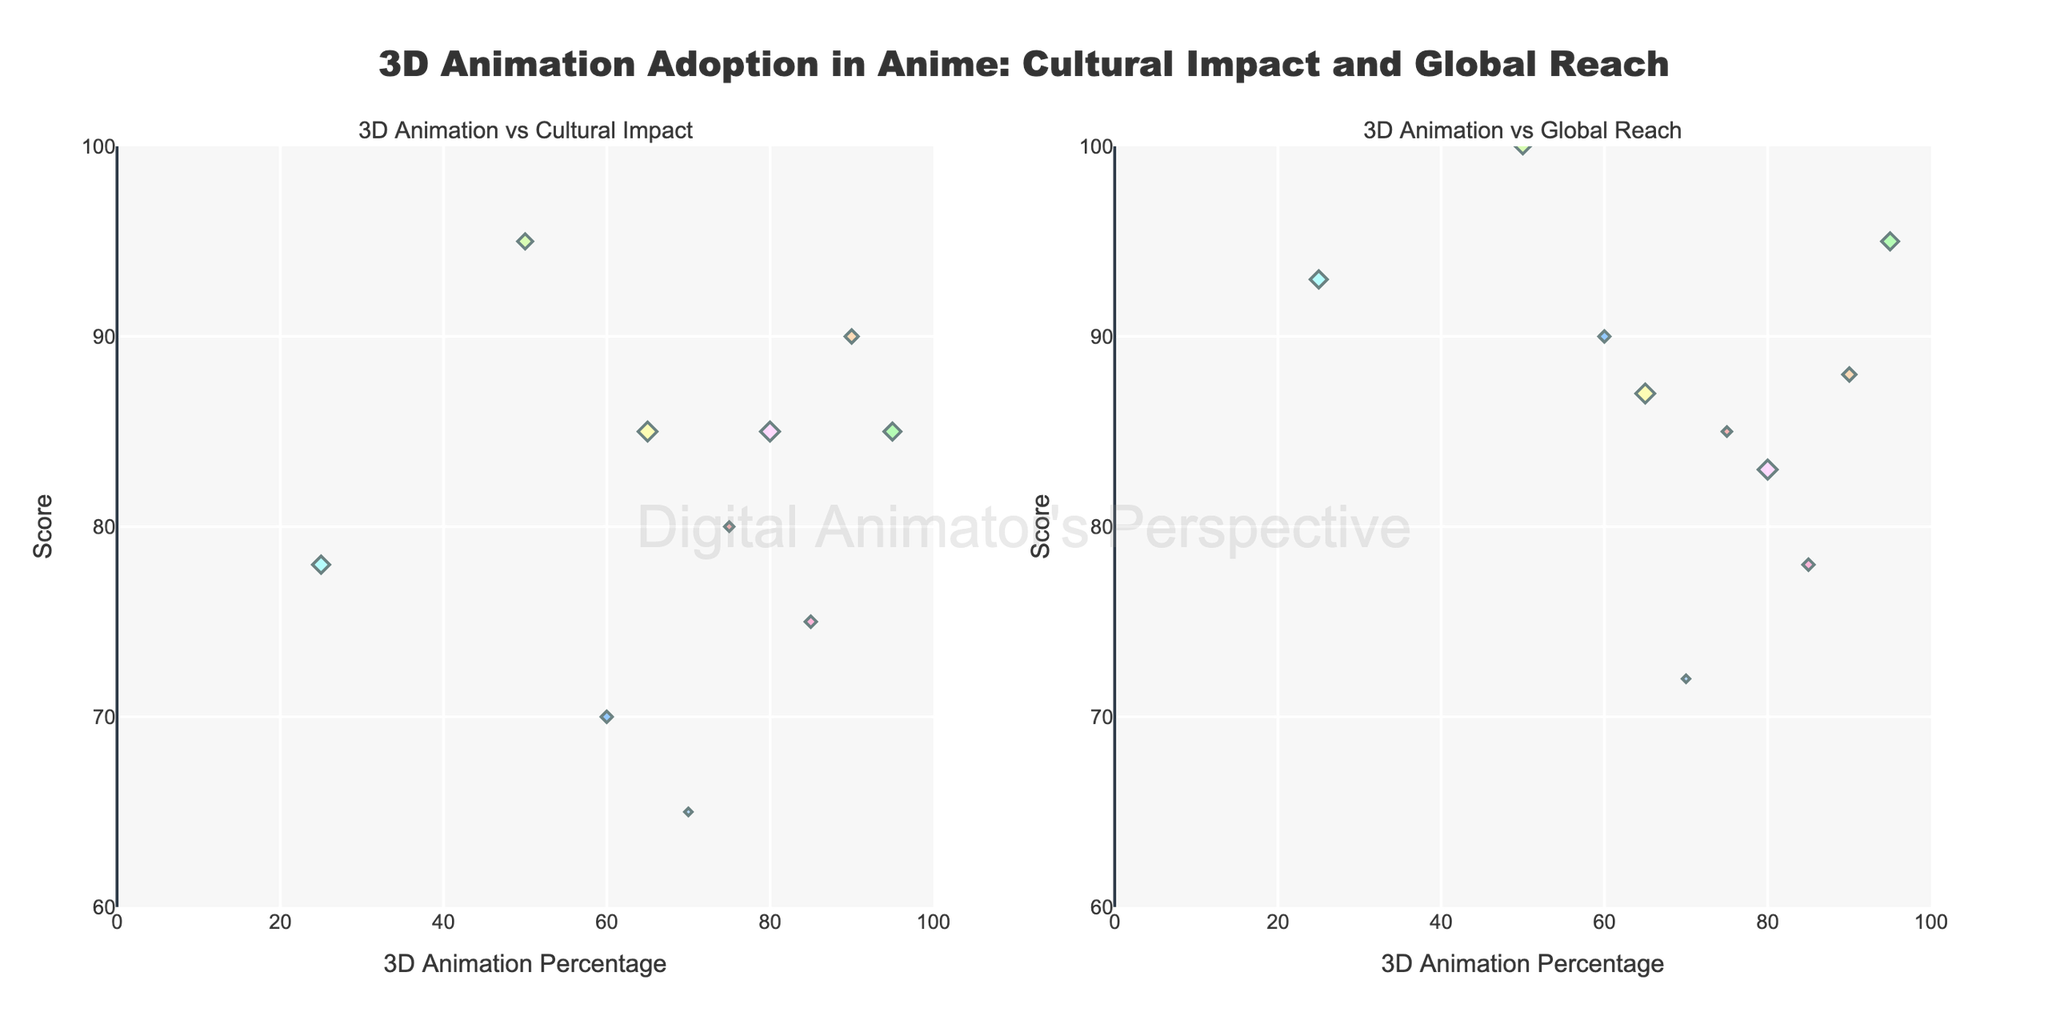What is the title of the plot? The title is printed in large font at the top center of the plot.
Answer: 3D Animation Adoption in Anime: Cultural Impact and Global Reach How many anime titles are plotted in total? Count the total number of unique markers (each representing an anime title) in both subplots.
Answer: 10 Which anime has the highest 3D Animation Percentage and what are its Cultural Impact Score and Global Reach Score? Identify the marker furthest to the right in both subplots, check the hover text for details.
Answer: Beastars, with a Cultural Impact Score of 85 and Global Reach Score of 95 What is the range of the Global Reach Score axis? Read the range from the y-axis of the subplot "3D Animation vs Global Reach".
Answer: 60 to 100 Which anime has the lowest 3D Animation Percentage and what are its Cultural Impact Score and Global Reach Score? Identify the marker furthest to the left in both subplots, check the hover text for details.
Answer: The Rising of the Shield Hero, with a Cultural Impact Score of 78 and Global Reach Score of 93 How many anime have a 3D Animation Percentage greater than 70%? Count the number of markers where the x-value (3D Animation Percentage) is greater than 70 in both subplots.
Answer: 7 Compare the Cultural Impact Score of 'Dragon Ball Super: Broly' and 'Ajin: Demi-Human'. Which one is higher and by how much? Find the markers for both anime, identify their Cultural Impact Scores from the hover text, and calculate the difference.
Answer: Dragon Ball Super: Broly has a higher Cultural Impact Score, 95 compared to 75, so it's higher by 20 Which anime title has a larger year size marker in both subplots, 'Love Live! Sunshine!!' or 'Land of the Lustrous'? Compare the size of the markers for both anime titles across both subplots.
Answer: Land of the Lustrous Which anime has a higher Global Reach Score than 'Dorohedoro' but a lower 3D Animation Percentage than 'Ajin: Demi-Human'? Identify 'Dorohedoro' and 'Ajin: Demi-Human' on the plot "3D Animation vs Global Reach", find an anime with a higher Global Reach Score than Dorohedoro's 83 and lower 3D Animation Percentage than Ajin's 85.
Answer: Ghost in the Shell: SAC_2045 